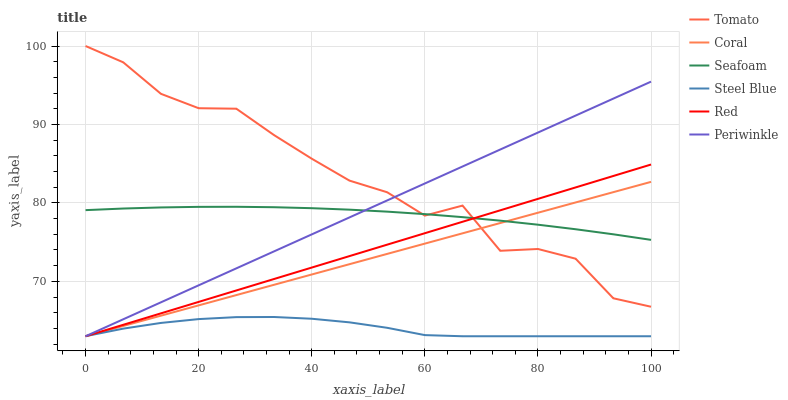Does Steel Blue have the minimum area under the curve?
Answer yes or no. Yes. Does Tomato have the maximum area under the curve?
Answer yes or no. Yes. Does Coral have the minimum area under the curve?
Answer yes or no. No. Does Coral have the maximum area under the curve?
Answer yes or no. No. Is Periwinkle the smoothest?
Answer yes or no. Yes. Is Tomato the roughest?
Answer yes or no. Yes. Is Coral the smoothest?
Answer yes or no. No. Is Coral the roughest?
Answer yes or no. No. Does Coral have the lowest value?
Answer yes or no. Yes. Does Seafoam have the lowest value?
Answer yes or no. No. Does Tomato have the highest value?
Answer yes or no. Yes. Does Coral have the highest value?
Answer yes or no. No. Is Steel Blue less than Seafoam?
Answer yes or no. Yes. Is Tomato greater than Steel Blue?
Answer yes or no. Yes. Does Red intersect Tomato?
Answer yes or no. Yes. Is Red less than Tomato?
Answer yes or no. No. Is Red greater than Tomato?
Answer yes or no. No. Does Steel Blue intersect Seafoam?
Answer yes or no. No. 